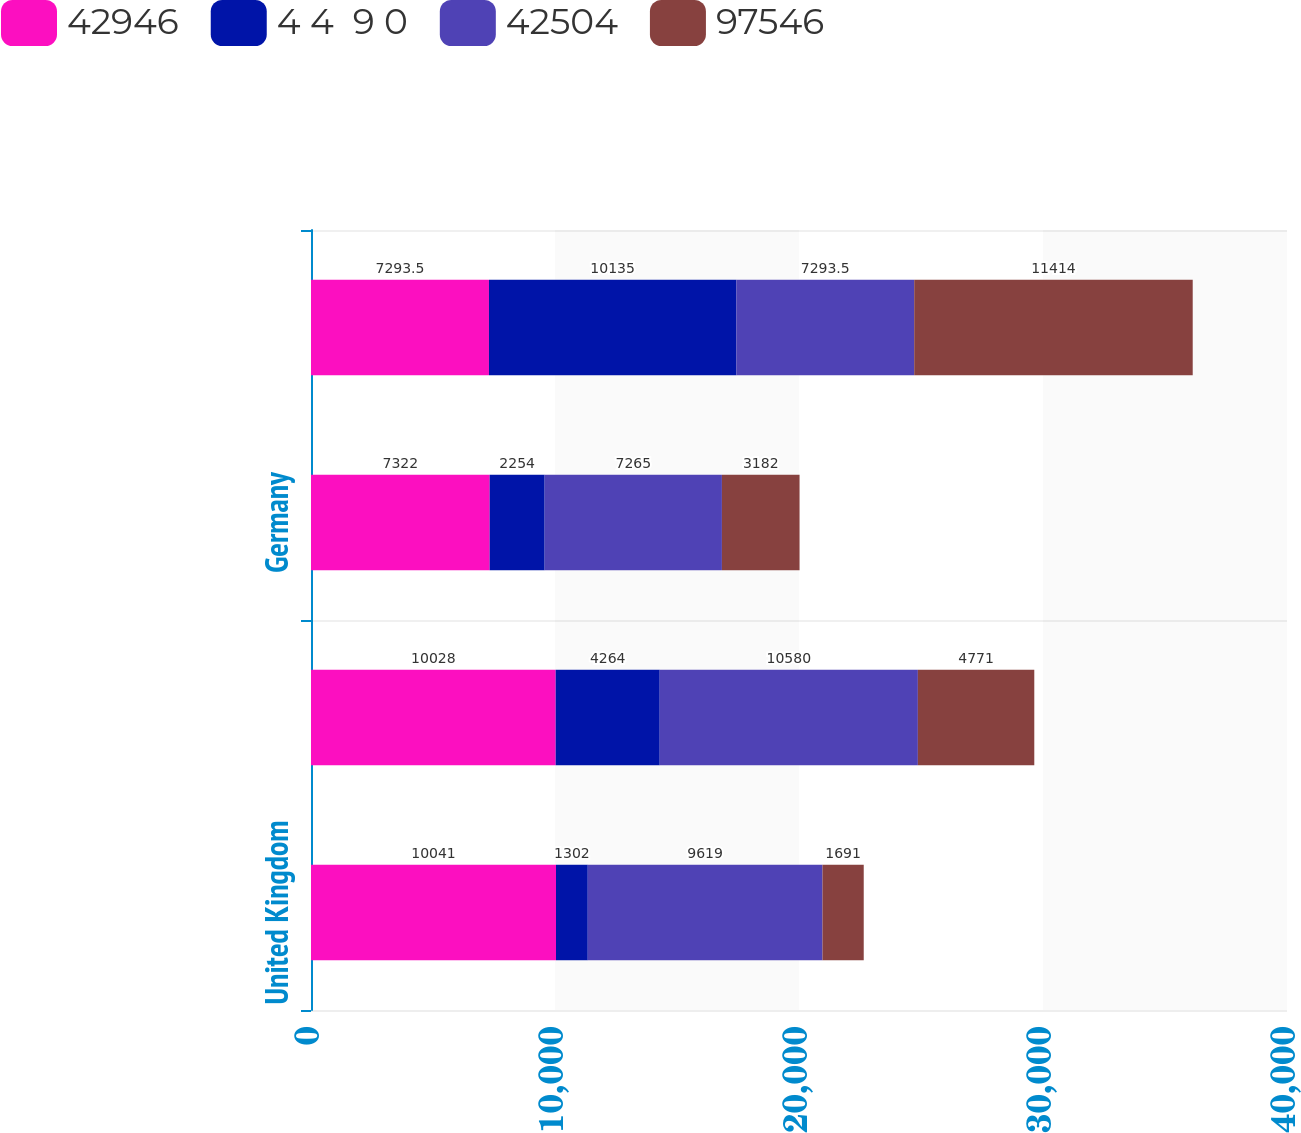Convert chart to OTSL. <chart><loc_0><loc_0><loc_500><loc_500><stacked_bar_chart><ecel><fcel>United Kingdom<fcel>Canada<fcel>Germany<fcel>All Other<nl><fcel>42946<fcel>10041<fcel>10028<fcel>7322<fcel>7293.5<nl><fcel>4 4  9 0<fcel>1302<fcel>4264<fcel>2254<fcel>10135<nl><fcel>42504<fcel>9619<fcel>10580<fcel>7265<fcel>7293.5<nl><fcel>97546<fcel>1691<fcel>4771<fcel>3182<fcel>11414<nl></chart> 